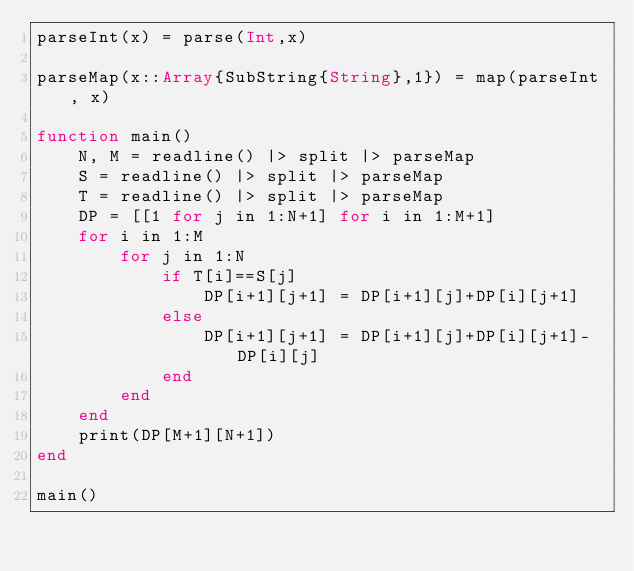Convert code to text. <code><loc_0><loc_0><loc_500><loc_500><_Julia_>parseInt(x) = parse(Int,x)

parseMap(x::Array{SubString{String},1}) = map(parseInt, x)

function main()
    N, M = readline() |> split |> parseMap
    S = readline() |> split |> parseMap
    T = readline() |> split |> parseMap
    DP = [[1 for j in 1:N+1] for i in 1:M+1]
    for i in 1:M
        for j in 1:N
            if T[i]==S[j]
                DP[i+1][j+1] = DP[i+1][j]+DP[i][j+1]
            else
                DP[i+1][j+1] = DP[i+1][j]+DP[i][j+1]-DP[i][j]
            end
        end
    end
    print(DP[M+1][N+1])
end

main()</code> 